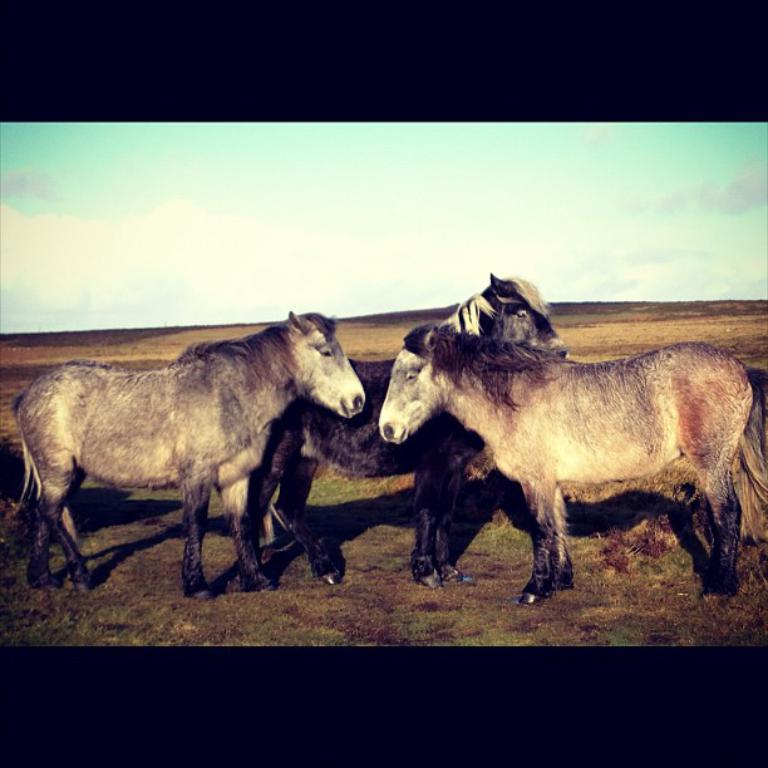How many horses are in the image? There are three horses standing in the image. What is visible at the top of the image? The sky is visible at the top of the image. What can be seen in the sky? There are clouds in the sky. What type of vegetation is present at the bottom of the image? Grass is present at the bottom of the image. What type of ornament is hanging from the baby's neck in the image? There is no baby or ornament present in the image; it features three horses and a sky with clouds. 